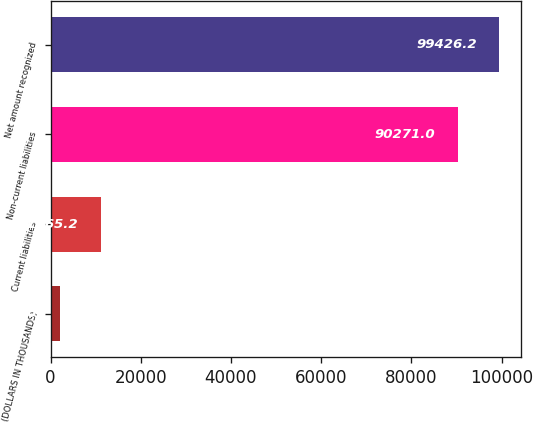<chart> <loc_0><loc_0><loc_500><loc_500><bar_chart><fcel>(DOLLARS IN THOUSANDS)<fcel>Current liabilities<fcel>Non-current liabilities<fcel>Net amount recognized<nl><fcel>2010<fcel>11165.2<fcel>90271<fcel>99426.2<nl></chart> 